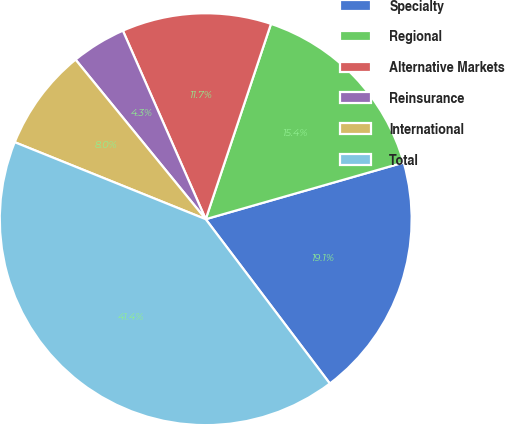<chart> <loc_0><loc_0><loc_500><loc_500><pie_chart><fcel>Specialty<fcel>Regional<fcel>Alternative Markets<fcel>Reinsurance<fcel>International<fcel>Total<nl><fcel>19.14%<fcel>15.43%<fcel>11.72%<fcel>4.3%<fcel>8.01%<fcel>41.39%<nl></chart> 